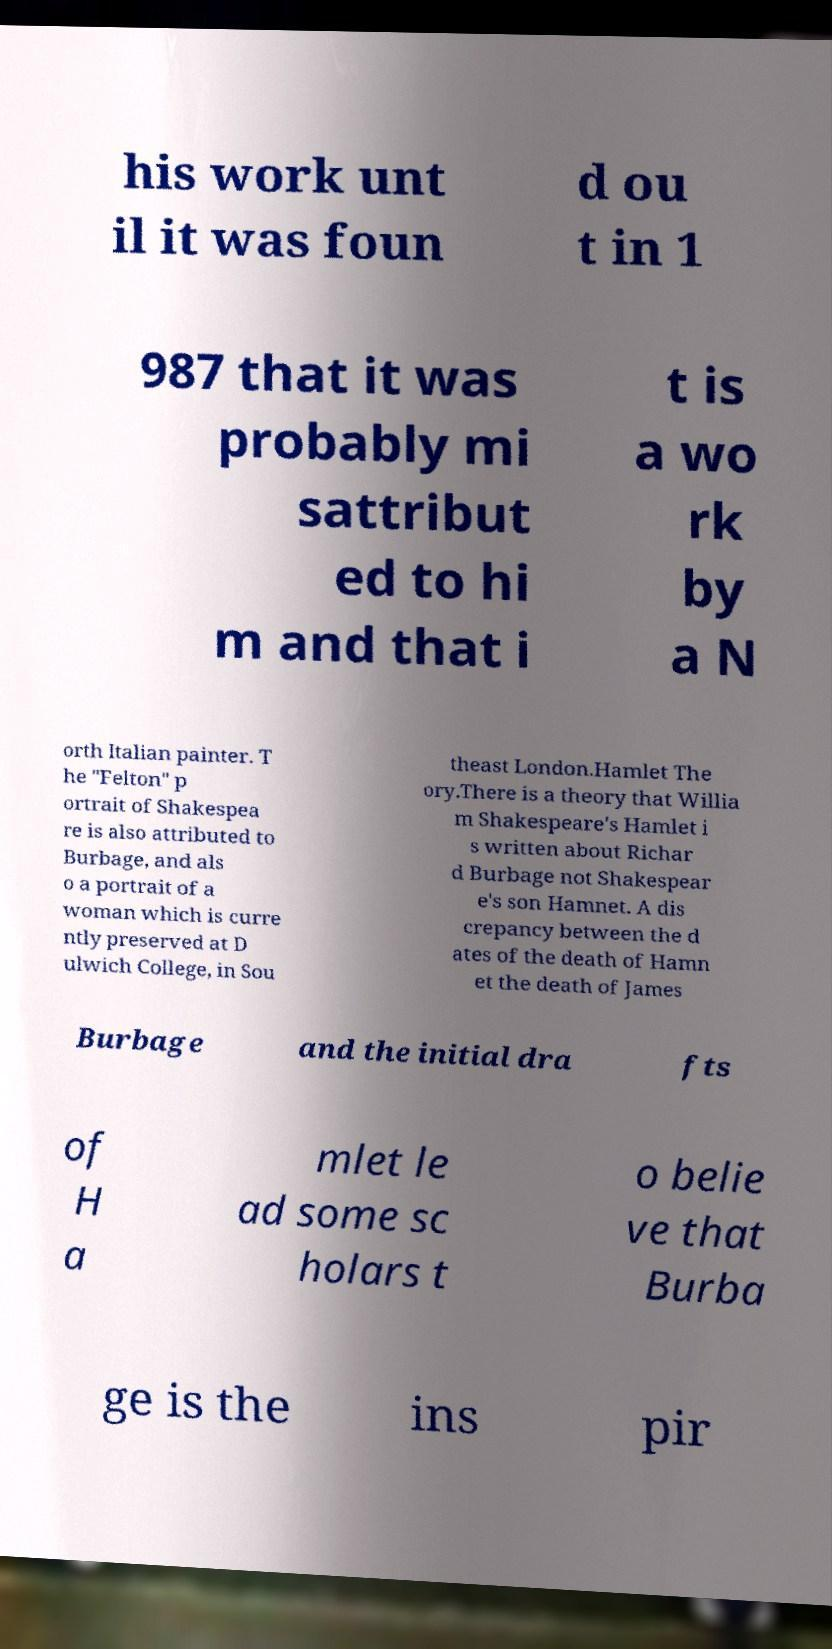I need the written content from this picture converted into text. Can you do that? his work unt il it was foun d ou t in 1 987 that it was probably mi sattribut ed to hi m and that i t is a wo rk by a N orth Italian painter. T he "Felton" p ortrait of Shakespea re is also attributed to Burbage, and als o a portrait of a woman which is curre ntly preserved at D ulwich College, in Sou theast London.Hamlet The ory.There is a theory that Willia m Shakespeare's Hamlet i s written about Richar d Burbage not Shakespear e's son Hamnet. A dis crepancy between the d ates of the death of Hamn et the death of James Burbage and the initial dra fts of H a mlet le ad some sc holars t o belie ve that Burba ge is the ins pir 